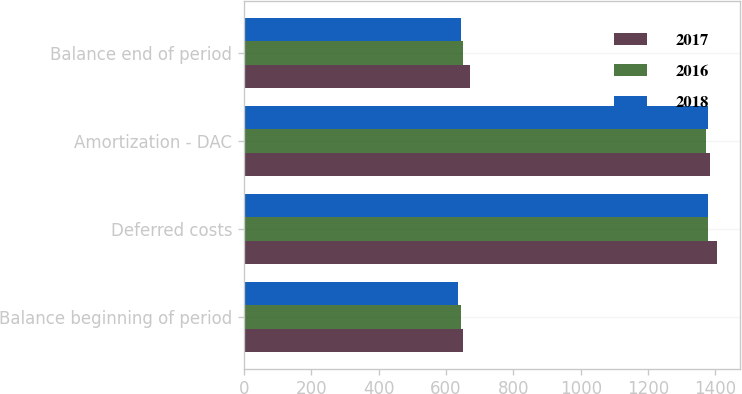Convert chart. <chart><loc_0><loc_0><loc_500><loc_500><stacked_bar_chart><ecel><fcel>Balance beginning of period<fcel>Deferred costs<fcel>Amortization - DAC<fcel>Balance end of period<nl><fcel>2017<fcel>650<fcel>1404<fcel>1384<fcel>670<nl><fcel>2016<fcel>645<fcel>1377<fcel>1372<fcel>650<nl><fcel>2018<fcel>636<fcel>1378<fcel>1377<fcel>645<nl></chart> 